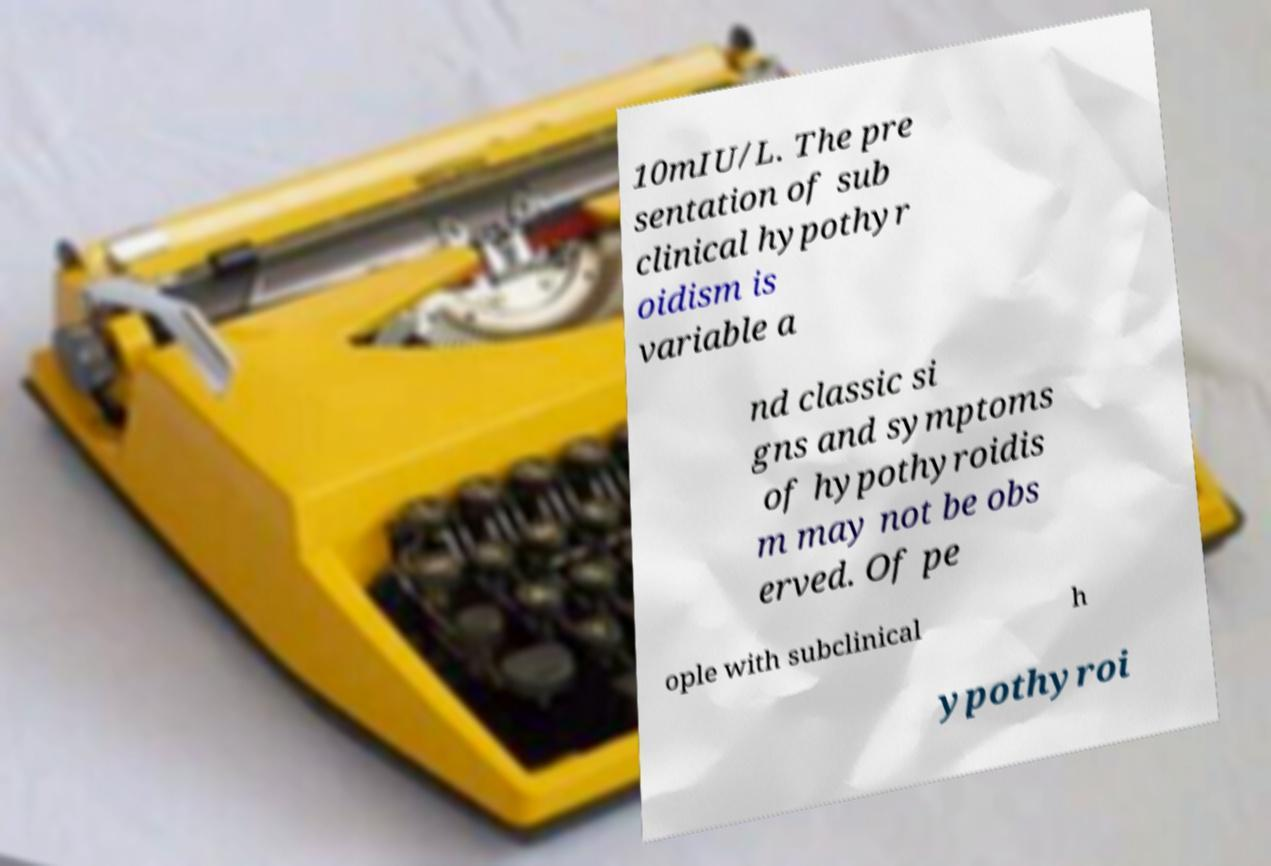Please read and relay the text visible in this image. What does it say? 10mIU/L. The pre sentation of sub clinical hypothyr oidism is variable a nd classic si gns and symptoms of hypothyroidis m may not be obs erved. Of pe ople with subclinical h ypothyroi 